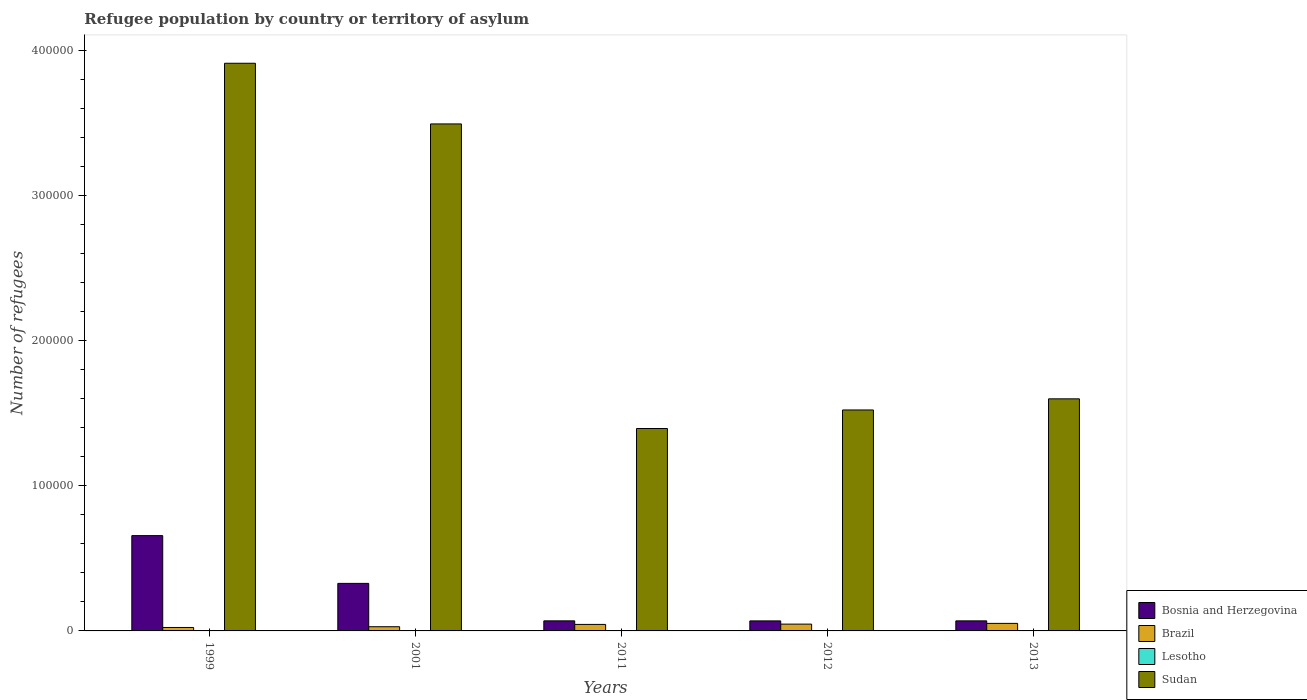How many different coloured bars are there?
Ensure brevity in your answer.  4. How many groups of bars are there?
Provide a succinct answer. 5. What is the number of refugees in Brazil in 2001?
Make the answer very short. 2884. Across all years, what is the maximum number of refugees in Sudan?
Offer a very short reply. 3.91e+05. Across all years, what is the minimum number of refugees in Bosnia and Herzegovina?
Make the answer very short. 6903. In which year was the number of refugees in Sudan minimum?
Your answer should be compact. 2011. What is the total number of refugees in Bosnia and Herzegovina in the graph?
Your response must be concise. 1.19e+05. What is the difference between the number of refugees in Lesotho in 1999 and that in 2012?
Your answer should be very brief. -33. What is the difference between the number of refugees in Lesotho in 2011 and the number of refugees in Sudan in 1999?
Your answer should be very brief. -3.91e+05. What is the average number of refugees in Brazil per year?
Your response must be concise. 3924.8. In the year 2013, what is the difference between the number of refugees in Sudan and number of refugees in Bosnia and Herzegovina?
Make the answer very short. 1.53e+05. In how many years, is the number of refugees in Bosnia and Herzegovina greater than 360000?
Offer a terse response. 0. What is the ratio of the number of refugees in Lesotho in 2001 to that in 2012?
Offer a terse response. 1.15. Is the number of refugees in Sudan in 2001 less than that in 2012?
Provide a short and direct response. No. What is the difference between the highest and the second highest number of refugees in Brazil?
Give a very brief answer. 507. What is the difference between the highest and the lowest number of refugees in Bosnia and Herzegovina?
Offer a terse response. 5.87e+04. In how many years, is the number of refugees in Sudan greater than the average number of refugees in Sudan taken over all years?
Ensure brevity in your answer.  2. Is it the case that in every year, the sum of the number of refugees in Sudan and number of refugees in Bosnia and Herzegovina is greater than the sum of number of refugees in Lesotho and number of refugees in Brazil?
Offer a very short reply. Yes. What does the 3rd bar from the left in 2012 represents?
Your answer should be very brief. Lesotho. What does the 1st bar from the right in 1999 represents?
Ensure brevity in your answer.  Sudan. Is it the case that in every year, the sum of the number of refugees in Lesotho and number of refugees in Sudan is greater than the number of refugees in Bosnia and Herzegovina?
Ensure brevity in your answer.  Yes. How many years are there in the graph?
Offer a terse response. 5. Are the values on the major ticks of Y-axis written in scientific E-notation?
Offer a very short reply. No. Does the graph contain any zero values?
Provide a succinct answer. No. Does the graph contain grids?
Your response must be concise. No. Where does the legend appear in the graph?
Your response must be concise. Bottom right. How many legend labels are there?
Provide a succinct answer. 4. How are the legend labels stacked?
Your answer should be very brief. Vertical. What is the title of the graph?
Provide a succinct answer. Refugee population by country or territory of asylum. Does "Algeria" appear as one of the legend labels in the graph?
Your response must be concise. No. What is the label or title of the Y-axis?
Your answer should be very brief. Number of refugees. What is the Number of refugees of Bosnia and Herzegovina in 1999?
Offer a terse response. 6.56e+04. What is the Number of refugees of Brazil in 1999?
Your response must be concise. 2378. What is the Number of refugees of Lesotho in 1999?
Give a very brief answer. 1. What is the Number of refugees in Sudan in 1999?
Ensure brevity in your answer.  3.91e+05. What is the Number of refugees in Bosnia and Herzegovina in 2001?
Make the answer very short. 3.27e+04. What is the Number of refugees of Brazil in 2001?
Give a very brief answer. 2884. What is the Number of refugees in Lesotho in 2001?
Your answer should be very brief. 39. What is the Number of refugees of Sudan in 2001?
Make the answer very short. 3.49e+05. What is the Number of refugees in Bosnia and Herzegovina in 2011?
Your answer should be very brief. 6933. What is the Number of refugees of Brazil in 2011?
Your answer should be compact. 4477. What is the Number of refugees of Lesotho in 2011?
Your response must be concise. 34. What is the Number of refugees in Sudan in 2011?
Your answer should be compact. 1.39e+05. What is the Number of refugees of Bosnia and Herzegovina in 2012?
Your response must be concise. 6903. What is the Number of refugees of Brazil in 2012?
Offer a very short reply. 4689. What is the Number of refugees in Sudan in 2012?
Give a very brief answer. 1.52e+05. What is the Number of refugees of Bosnia and Herzegovina in 2013?
Provide a succinct answer. 6926. What is the Number of refugees of Brazil in 2013?
Your answer should be compact. 5196. What is the Number of refugees in Lesotho in 2013?
Make the answer very short. 30. What is the Number of refugees in Sudan in 2013?
Your answer should be compact. 1.60e+05. Across all years, what is the maximum Number of refugees in Bosnia and Herzegovina?
Offer a very short reply. 6.56e+04. Across all years, what is the maximum Number of refugees of Brazil?
Ensure brevity in your answer.  5196. Across all years, what is the maximum Number of refugees of Lesotho?
Provide a short and direct response. 39. Across all years, what is the maximum Number of refugees in Sudan?
Your answer should be compact. 3.91e+05. Across all years, what is the minimum Number of refugees in Bosnia and Herzegovina?
Ensure brevity in your answer.  6903. Across all years, what is the minimum Number of refugees of Brazil?
Provide a short and direct response. 2378. Across all years, what is the minimum Number of refugees in Sudan?
Your response must be concise. 1.39e+05. What is the total Number of refugees in Bosnia and Herzegovina in the graph?
Give a very brief answer. 1.19e+05. What is the total Number of refugees in Brazil in the graph?
Offer a terse response. 1.96e+04. What is the total Number of refugees of Lesotho in the graph?
Keep it short and to the point. 138. What is the total Number of refugees in Sudan in the graph?
Provide a succinct answer. 1.19e+06. What is the difference between the Number of refugees of Bosnia and Herzegovina in 1999 and that in 2001?
Your response must be concise. 3.29e+04. What is the difference between the Number of refugees in Brazil in 1999 and that in 2001?
Your answer should be very brief. -506. What is the difference between the Number of refugees in Lesotho in 1999 and that in 2001?
Your answer should be compact. -38. What is the difference between the Number of refugees in Sudan in 1999 and that in 2001?
Offer a terse response. 4.18e+04. What is the difference between the Number of refugees in Bosnia and Herzegovina in 1999 and that in 2011?
Provide a short and direct response. 5.87e+04. What is the difference between the Number of refugees of Brazil in 1999 and that in 2011?
Make the answer very short. -2099. What is the difference between the Number of refugees of Lesotho in 1999 and that in 2011?
Ensure brevity in your answer.  -33. What is the difference between the Number of refugees in Sudan in 1999 and that in 2011?
Offer a very short reply. 2.52e+05. What is the difference between the Number of refugees of Bosnia and Herzegovina in 1999 and that in 2012?
Your answer should be compact. 5.87e+04. What is the difference between the Number of refugees in Brazil in 1999 and that in 2012?
Give a very brief answer. -2311. What is the difference between the Number of refugees in Lesotho in 1999 and that in 2012?
Provide a succinct answer. -33. What is the difference between the Number of refugees in Sudan in 1999 and that in 2012?
Ensure brevity in your answer.  2.39e+05. What is the difference between the Number of refugees in Bosnia and Herzegovina in 1999 and that in 2013?
Ensure brevity in your answer.  5.87e+04. What is the difference between the Number of refugees of Brazil in 1999 and that in 2013?
Give a very brief answer. -2818. What is the difference between the Number of refugees of Sudan in 1999 and that in 2013?
Provide a succinct answer. 2.31e+05. What is the difference between the Number of refugees of Bosnia and Herzegovina in 2001 and that in 2011?
Offer a terse response. 2.58e+04. What is the difference between the Number of refugees of Brazil in 2001 and that in 2011?
Your response must be concise. -1593. What is the difference between the Number of refugees of Lesotho in 2001 and that in 2011?
Make the answer very short. 5. What is the difference between the Number of refugees in Sudan in 2001 and that in 2011?
Your answer should be compact. 2.10e+05. What is the difference between the Number of refugees of Bosnia and Herzegovina in 2001 and that in 2012?
Make the answer very short. 2.58e+04. What is the difference between the Number of refugees of Brazil in 2001 and that in 2012?
Provide a short and direct response. -1805. What is the difference between the Number of refugees in Sudan in 2001 and that in 2012?
Ensure brevity in your answer.  1.97e+05. What is the difference between the Number of refugees of Bosnia and Herzegovina in 2001 and that in 2013?
Offer a very short reply. 2.58e+04. What is the difference between the Number of refugees of Brazil in 2001 and that in 2013?
Offer a terse response. -2312. What is the difference between the Number of refugees of Lesotho in 2001 and that in 2013?
Offer a terse response. 9. What is the difference between the Number of refugees in Sudan in 2001 and that in 2013?
Provide a succinct answer. 1.89e+05. What is the difference between the Number of refugees of Brazil in 2011 and that in 2012?
Your answer should be compact. -212. What is the difference between the Number of refugees in Lesotho in 2011 and that in 2012?
Offer a very short reply. 0. What is the difference between the Number of refugees of Sudan in 2011 and that in 2012?
Ensure brevity in your answer.  -1.28e+04. What is the difference between the Number of refugees of Brazil in 2011 and that in 2013?
Your answer should be compact. -719. What is the difference between the Number of refugees in Lesotho in 2011 and that in 2013?
Ensure brevity in your answer.  4. What is the difference between the Number of refugees in Sudan in 2011 and that in 2013?
Keep it short and to the point. -2.04e+04. What is the difference between the Number of refugees in Bosnia and Herzegovina in 2012 and that in 2013?
Give a very brief answer. -23. What is the difference between the Number of refugees in Brazil in 2012 and that in 2013?
Provide a succinct answer. -507. What is the difference between the Number of refugees of Lesotho in 2012 and that in 2013?
Ensure brevity in your answer.  4. What is the difference between the Number of refugees of Sudan in 2012 and that in 2013?
Your response must be concise. -7663. What is the difference between the Number of refugees of Bosnia and Herzegovina in 1999 and the Number of refugees of Brazil in 2001?
Your answer should be very brief. 6.28e+04. What is the difference between the Number of refugees of Bosnia and Herzegovina in 1999 and the Number of refugees of Lesotho in 2001?
Provide a succinct answer. 6.56e+04. What is the difference between the Number of refugees in Bosnia and Herzegovina in 1999 and the Number of refugees in Sudan in 2001?
Provide a short and direct response. -2.84e+05. What is the difference between the Number of refugees of Brazil in 1999 and the Number of refugees of Lesotho in 2001?
Make the answer very short. 2339. What is the difference between the Number of refugees in Brazil in 1999 and the Number of refugees in Sudan in 2001?
Your answer should be very brief. -3.47e+05. What is the difference between the Number of refugees in Lesotho in 1999 and the Number of refugees in Sudan in 2001?
Ensure brevity in your answer.  -3.49e+05. What is the difference between the Number of refugees in Bosnia and Herzegovina in 1999 and the Number of refugees in Brazil in 2011?
Make the answer very short. 6.12e+04. What is the difference between the Number of refugees of Bosnia and Herzegovina in 1999 and the Number of refugees of Lesotho in 2011?
Your answer should be compact. 6.56e+04. What is the difference between the Number of refugees in Bosnia and Herzegovina in 1999 and the Number of refugees in Sudan in 2011?
Your answer should be very brief. -7.38e+04. What is the difference between the Number of refugees in Brazil in 1999 and the Number of refugees in Lesotho in 2011?
Make the answer very short. 2344. What is the difference between the Number of refugees in Brazil in 1999 and the Number of refugees in Sudan in 2011?
Offer a very short reply. -1.37e+05. What is the difference between the Number of refugees of Lesotho in 1999 and the Number of refugees of Sudan in 2011?
Your answer should be very brief. -1.39e+05. What is the difference between the Number of refugees of Bosnia and Herzegovina in 1999 and the Number of refugees of Brazil in 2012?
Offer a very short reply. 6.10e+04. What is the difference between the Number of refugees in Bosnia and Herzegovina in 1999 and the Number of refugees in Lesotho in 2012?
Your response must be concise. 6.56e+04. What is the difference between the Number of refugees of Bosnia and Herzegovina in 1999 and the Number of refugees of Sudan in 2012?
Provide a short and direct response. -8.65e+04. What is the difference between the Number of refugees in Brazil in 1999 and the Number of refugees in Lesotho in 2012?
Provide a short and direct response. 2344. What is the difference between the Number of refugees in Brazil in 1999 and the Number of refugees in Sudan in 2012?
Ensure brevity in your answer.  -1.50e+05. What is the difference between the Number of refugees of Lesotho in 1999 and the Number of refugees of Sudan in 2012?
Offer a terse response. -1.52e+05. What is the difference between the Number of refugees in Bosnia and Herzegovina in 1999 and the Number of refugees in Brazil in 2013?
Your answer should be very brief. 6.04e+04. What is the difference between the Number of refugees in Bosnia and Herzegovina in 1999 and the Number of refugees in Lesotho in 2013?
Offer a terse response. 6.56e+04. What is the difference between the Number of refugees in Bosnia and Herzegovina in 1999 and the Number of refugees in Sudan in 2013?
Make the answer very short. -9.42e+04. What is the difference between the Number of refugees of Brazil in 1999 and the Number of refugees of Lesotho in 2013?
Provide a succinct answer. 2348. What is the difference between the Number of refugees of Brazil in 1999 and the Number of refugees of Sudan in 2013?
Offer a terse response. -1.57e+05. What is the difference between the Number of refugees of Lesotho in 1999 and the Number of refugees of Sudan in 2013?
Offer a very short reply. -1.60e+05. What is the difference between the Number of refugees in Bosnia and Herzegovina in 2001 and the Number of refugees in Brazil in 2011?
Your response must be concise. 2.83e+04. What is the difference between the Number of refugees of Bosnia and Herzegovina in 2001 and the Number of refugees of Lesotho in 2011?
Your answer should be very brief. 3.27e+04. What is the difference between the Number of refugees in Bosnia and Herzegovina in 2001 and the Number of refugees in Sudan in 2011?
Keep it short and to the point. -1.07e+05. What is the difference between the Number of refugees in Brazil in 2001 and the Number of refugees in Lesotho in 2011?
Your answer should be very brief. 2850. What is the difference between the Number of refugees in Brazil in 2001 and the Number of refugees in Sudan in 2011?
Give a very brief answer. -1.37e+05. What is the difference between the Number of refugees of Lesotho in 2001 and the Number of refugees of Sudan in 2011?
Your answer should be very brief. -1.39e+05. What is the difference between the Number of refugees in Bosnia and Herzegovina in 2001 and the Number of refugees in Brazil in 2012?
Keep it short and to the point. 2.81e+04. What is the difference between the Number of refugees of Bosnia and Herzegovina in 2001 and the Number of refugees of Lesotho in 2012?
Provide a short and direct response. 3.27e+04. What is the difference between the Number of refugees of Bosnia and Herzegovina in 2001 and the Number of refugees of Sudan in 2012?
Offer a terse response. -1.19e+05. What is the difference between the Number of refugees in Brazil in 2001 and the Number of refugees in Lesotho in 2012?
Offer a terse response. 2850. What is the difference between the Number of refugees of Brazil in 2001 and the Number of refugees of Sudan in 2012?
Offer a very short reply. -1.49e+05. What is the difference between the Number of refugees of Lesotho in 2001 and the Number of refugees of Sudan in 2012?
Ensure brevity in your answer.  -1.52e+05. What is the difference between the Number of refugees in Bosnia and Herzegovina in 2001 and the Number of refugees in Brazil in 2013?
Your response must be concise. 2.75e+04. What is the difference between the Number of refugees of Bosnia and Herzegovina in 2001 and the Number of refugees of Lesotho in 2013?
Ensure brevity in your answer.  3.27e+04. What is the difference between the Number of refugees in Bosnia and Herzegovina in 2001 and the Number of refugees in Sudan in 2013?
Your answer should be very brief. -1.27e+05. What is the difference between the Number of refugees in Brazil in 2001 and the Number of refugees in Lesotho in 2013?
Your answer should be compact. 2854. What is the difference between the Number of refugees in Brazil in 2001 and the Number of refugees in Sudan in 2013?
Provide a succinct answer. -1.57e+05. What is the difference between the Number of refugees in Lesotho in 2001 and the Number of refugees in Sudan in 2013?
Provide a succinct answer. -1.60e+05. What is the difference between the Number of refugees of Bosnia and Herzegovina in 2011 and the Number of refugees of Brazil in 2012?
Your answer should be very brief. 2244. What is the difference between the Number of refugees of Bosnia and Herzegovina in 2011 and the Number of refugees of Lesotho in 2012?
Your response must be concise. 6899. What is the difference between the Number of refugees of Bosnia and Herzegovina in 2011 and the Number of refugees of Sudan in 2012?
Your answer should be very brief. -1.45e+05. What is the difference between the Number of refugees of Brazil in 2011 and the Number of refugees of Lesotho in 2012?
Make the answer very short. 4443. What is the difference between the Number of refugees of Brazil in 2011 and the Number of refugees of Sudan in 2012?
Your answer should be compact. -1.48e+05. What is the difference between the Number of refugees of Lesotho in 2011 and the Number of refugees of Sudan in 2012?
Ensure brevity in your answer.  -1.52e+05. What is the difference between the Number of refugees of Bosnia and Herzegovina in 2011 and the Number of refugees of Brazil in 2013?
Keep it short and to the point. 1737. What is the difference between the Number of refugees in Bosnia and Herzegovina in 2011 and the Number of refugees in Lesotho in 2013?
Your response must be concise. 6903. What is the difference between the Number of refugees in Bosnia and Herzegovina in 2011 and the Number of refugees in Sudan in 2013?
Your response must be concise. -1.53e+05. What is the difference between the Number of refugees of Brazil in 2011 and the Number of refugees of Lesotho in 2013?
Make the answer very short. 4447. What is the difference between the Number of refugees in Brazil in 2011 and the Number of refugees in Sudan in 2013?
Give a very brief answer. -1.55e+05. What is the difference between the Number of refugees of Lesotho in 2011 and the Number of refugees of Sudan in 2013?
Offer a terse response. -1.60e+05. What is the difference between the Number of refugees of Bosnia and Herzegovina in 2012 and the Number of refugees of Brazil in 2013?
Your response must be concise. 1707. What is the difference between the Number of refugees in Bosnia and Herzegovina in 2012 and the Number of refugees in Lesotho in 2013?
Provide a short and direct response. 6873. What is the difference between the Number of refugees in Bosnia and Herzegovina in 2012 and the Number of refugees in Sudan in 2013?
Your answer should be very brief. -1.53e+05. What is the difference between the Number of refugees of Brazil in 2012 and the Number of refugees of Lesotho in 2013?
Your response must be concise. 4659. What is the difference between the Number of refugees of Brazil in 2012 and the Number of refugees of Sudan in 2013?
Your response must be concise. -1.55e+05. What is the difference between the Number of refugees of Lesotho in 2012 and the Number of refugees of Sudan in 2013?
Make the answer very short. -1.60e+05. What is the average Number of refugees in Bosnia and Herzegovina per year?
Offer a terse response. 2.38e+04. What is the average Number of refugees in Brazil per year?
Provide a succinct answer. 3924.8. What is the average Number of refugees in Lesotho per year?
Provide a short and direct response. 27.6. What is the average Number of refugees in Sudan per year?
Your answer should be very brief. 2.38e+05. In the year 1999, what is the difference between the Number of refugees in Bosnia and Herzegovina and Number of refugees in Brazil?
Provide a short and direct response. 6.33e+04. In the year 1999, what is the difference between the Number of refugees in Bosnia and Herzegovina and Number of refugees in Lesotho?
Offer a terse response. 6.56e+04. In the year 1999, what is the difference between the Number of refugees of Bosnia and Herzegovina and Number of refugees of Sudan?
Make the answer very short. -3.25e+05. In the year 1999, what is the difference between the Number of refugees of Brazil and Number of refugees of Lesotho?
Your response must be concise. 2377. In the year 1999, what is the difference between the Number of refugees of Brazil and Number of refugees of Sudan?
Offer a terse response. -3.89e+05. In the year 1999, what is the difference between the Number of refugees of Lesotho and Number of refugees of Sudan?
Your answer should be very brief. -3.91e+05. In the year 2001, what is the difference between the Number of refugees in Bosnia and Herzegovina and Number of refugees in Brazil?
Your answer should be very brief. 2.99e+04. In the year 2001, what is the difference between the Number of refugees in Bosnia and Herzegovina and Number of refugees in Lesotho?
Offer a very short reply. 3.27e+04. In the year 2001, what is the difference between the Number of refugees in Bosnia and Herzegovina and Number of refugees in Sudan?
Your answer should be very brief. -3.16e+05. In the year 2001, what is the difference between the Number of refugees in Brazil and Number of refugees in Lesotho?
Give a very brief answer. 2845. In the year 2001, what is the difference between the Number of refugees of Brazil and Number of refugees of Sudan?
Your response must be concise. -3.46e+05. In the year 2001, what is the difference between the Number of refugees of Lesotho and Number of refugees of Sudan?
Your response must be concise. -3.49e+05. In the year 2011, what is the difference between the Number of refugees in Bosnia and Herzegovina and Number of refugees in Brazil?
Your response must be concise. 2456. In the year 2011, what is the difference between the Number of refugees of Bosnia and Herzegovina and Number of refugees of Lesotho?
Your response must be concise. 6899. In the year 2011, what is the difference between the Number of refugees of Bosnia and Herzegovina and Number of refugees of Sudan?
Provide a short and direct response. -1.32e+05. In the year 2011, what is the difference between the Number of refugees of Brazil and Number of refugees of Lesotho?
Provide a short and direct response. 4443. In the year 2011, what is the difference between the Number of refugees of Brazil and Number of refugees of Sudan?
Provide a short and direct response. -1.35e+05. In the year 2011, what is the difference between the Number of refugees of Lesotho and Number of refugees of Sudan?
Offer a very short reply. -1.39e+05. In the year 2012, what is the difference between the Number of refugees in Bosnia and Herzegovina and Number of refugees in Brazil?
Your response must be concise. 2214. In the year 2012, what is the difference between the Number of refugees of Bosnia and Herzegovina and Number of refugees of Lesotho?
Offer a terse response. 6869. In the year 2012, what is the difference between the Number of refugees of Bosnia and Herzegovina and Number of refugees of Sudan?
Make the answer very short. -1.45e+05. In the year 2012, what is the difference between the Number of refugees of Brazil and Number of refugees of Lesotho?
Give a very brief answer. 4655. In the year 2012, what is the difference between the Number of refugees in Brazil and Number of refugees in Sudan?
Your answer should be very brief. -1.48e+05. In the year 2012, what is the difference between the Number of refugees of Lesotho and Number of refugees of Sudan?
Your answer should be very brief. -1.52e+05. In the year 2013, what is the difference between the Number of refugees of Bosnia and Herzegovina and Number of refugees of Brazil?
Your answer should be compact. 1730. In the year 2013, what is the difference between the Number of refugees in Bosnia and Herzegovina and Number of refugees in Lesotho?
Make the answer very short. 6896. In the year 2013, what is the difference between the Number of refugees in Bosnia and Herzegovina and Number of refugees in Sudan?
Provide a short and direct response. -1.53e+05. In the year 2013, what is the difference between the Number of refugees of Brazil and Number of refugees of Lesotho?
Keep it short and to the point. 5166. In the year 2013, what is the difference between the Number of refugees in Brazil and Number of refugees in Sudan?
Ensure brevity in your answer.  -1.55e+05. In the year 2013, what is the difference between the Number of refugees in Lesotho and Number of refugees in Sudan?
Give a very brief answer. -1.60e+05. What is the ratio of the Number of refugees of Bosnia and Herzegovina in 1999 to that in 2001?
Your answer should be compact. 2. What is the ratio of the Number of refugees in Brazil in 1999 to that in 2001?
Provide a succinct answer. 0.82. What is the ratio of the Number of refugees in Lesotho in 1999 to that in 2001?
Make the answer very short. 0.03. What is the ratio of the Number of refugees in Sudan in 1999 to that in 2001?
Your response must be concise. 1.12. What is the ratio of the Number of refugees of Bosnia and Herzegovina in 1999 to that in 2011?
Give a very brief answer. 9.47. What is the ratio of the Number of refugees in Brazil in 1999 to that in 2011?
Your response must be concise. 0.53. What is the ratio of the Number of refugees of Lesotho in 1999 to that in 2011?
Your response must be concise. 0.03. What is the ratio of the Number of refugees in Sudan in 1999 to that in 2011?
Offer a terse response. 2.8. What is the ratio of the Number of refugees of Bosnia and Herzegovina in 1999 to that in 2012?
Make the answer very short. 9.51. What is the ratio of the Number of refugees of Brazil in 1999 to that in 2012?
Make the answer very short. 0.51. What is the ratio of the Number of refugees of Lesotho in 1999 to that in 2012?
Provide a succinct answer. 0.03. What is the ratio of the Number of refugees in Sudan in 1999 to that in 2012?
Ensure brevity in your answer.  2.57. What is the ratio of the Number of refugees in Bosnia and Herzegovina in 1999 to that in 2013?
Ensure brevity in your answer.  9.48. What is the ratio of the Number of refugees in Brazil in 1999 to that in 2013?
Keep it short and to the point. 0.46. What is the ratio of the Number of refugees in Lesotho in 1999 to that in 2013?
Offer a very short reply. 0.03. What is the ratio of the Number of refugees in Sudan in 1999 to that in 2013?
Offer a very short reply. 2.45. What is the ratio of the Number of refugees of Bosnia and Herzegovina in 2001 to that in 2011?
Offer a terse response. 4.72. What is the ratio of the Number of refugees of Brazil in 2001 to that in 2011?
Keep it short and to the point. 0.64. What is the ratio of the Number of refugees of Lesotho in 2001 to that in 2011?
Make the answer very short. 1.15. What is the ratio of the Number of refugees in Sudan in 2001 to that in 2011?
Provide a short and direct response. 2.5. What is the ratio of the Number of refugees of Bosnia and Herzegovina in 2001 to that in 2012?
Offer a terse response. 4.74. What is the ratio of the Number of refugees in Brazil in 2001 to that in 2012?
Make the answer very short. 0.62. What is the ratio of the Number of refugees in Lesotho in 2001 to that in 2012?
Provide a succinct answer. 1.15. What is the ratio of the Number of refugees of Sudan in 2001 to that in 2012?
Your answer should be very brief. 2.29. What is the ratio of the Number of refugees in Bosnia and Herzegovina in 2001 to that in 2013?
Offer a terse response. 4.73. What is the ratio of the Number of refugees in Brazil in 2001 to that in 2013?
Your response must be concise. 0.56. What is the ratio of the Number of refugees of Lesotho in 2001 to that in 2013?
Provide a short and direct response. 1.3. What is the ratio of the Number of refugees of Sudan in 2001 to that in 2013?
Keep it short and to the point. 2.18. What is the ratio of the Number of refugees of Bosnia and Herzegovina in 2011 to that in 2012?
Your answer should be compact. 1. What is the ratio of the Number of refugees in Brazil in 2011 to that in 2012?
Keep it short and to the point. 0.95. What is the ratio of the Number of refugees in Lesotho in 2011 to that in 2012?
Your answer should be very brief. 1. What is the ratio of the Number of refugees of Sudan in 2011 to that in 2012?
Make the answer very short. 0.92. What is the ratio of the Number of refugees of Brazil in 2011 to that in 2013?
Give a very brief answer. 0.86. What is the ratio of the Number of refugees in Lesotho in 2011 to that in 2013?
Provide a succinct answer. 1.13. What is the ratio of the Number of refugees in Sudan in 2011 to that in 2013?
Give a very brief answer. 0.87. What is the ratio of the Number of refugees of Bosnia and Herzegovina in 2012 to that in 2013?
Provide a succinct answer. 1. What is the ratio of the Number of refugees of Brazil in 2012 to that in 2013?
Offer a terse response. 0.9. What is the ratio of the Number of refugees of Lesotho in 2012 to that in 2013?
Provide a succinct answer. 1.13. What is the ratio of the Number of refugees of Sudan in 2012 to that in 2013?
Ensure brevity in your answer.  0.95. What is the difference between the highest and the second highest Number of refugees in Bosnia and Herzegovina?
Offer a very short reply. 3.29e+04. What is the difference between the highest and the second highest Number of refugees of Brazil?
Give a very brief answer. 507. What is the difference between the highest and the second highest Number of refugees in Lesotho?
Give a very brief answer. 5. What is the difference between the highest and the second highest Number of refugees in Sudan?
Keep it short and to the point. 4.18e+04. What is the difference between the highest and the lowest Number of refugees in Bosnia and Herzegovina?
Ensure brevity in your answer.  5.87e+04. What is the difference between the highest and the lowest Number of refugees in Brazil?
Offer a very short reply. 2818. What is the difference between the highest and the lowest Number of refugees of Sudan?
Provide a short and direct response. 2.52e+05. 